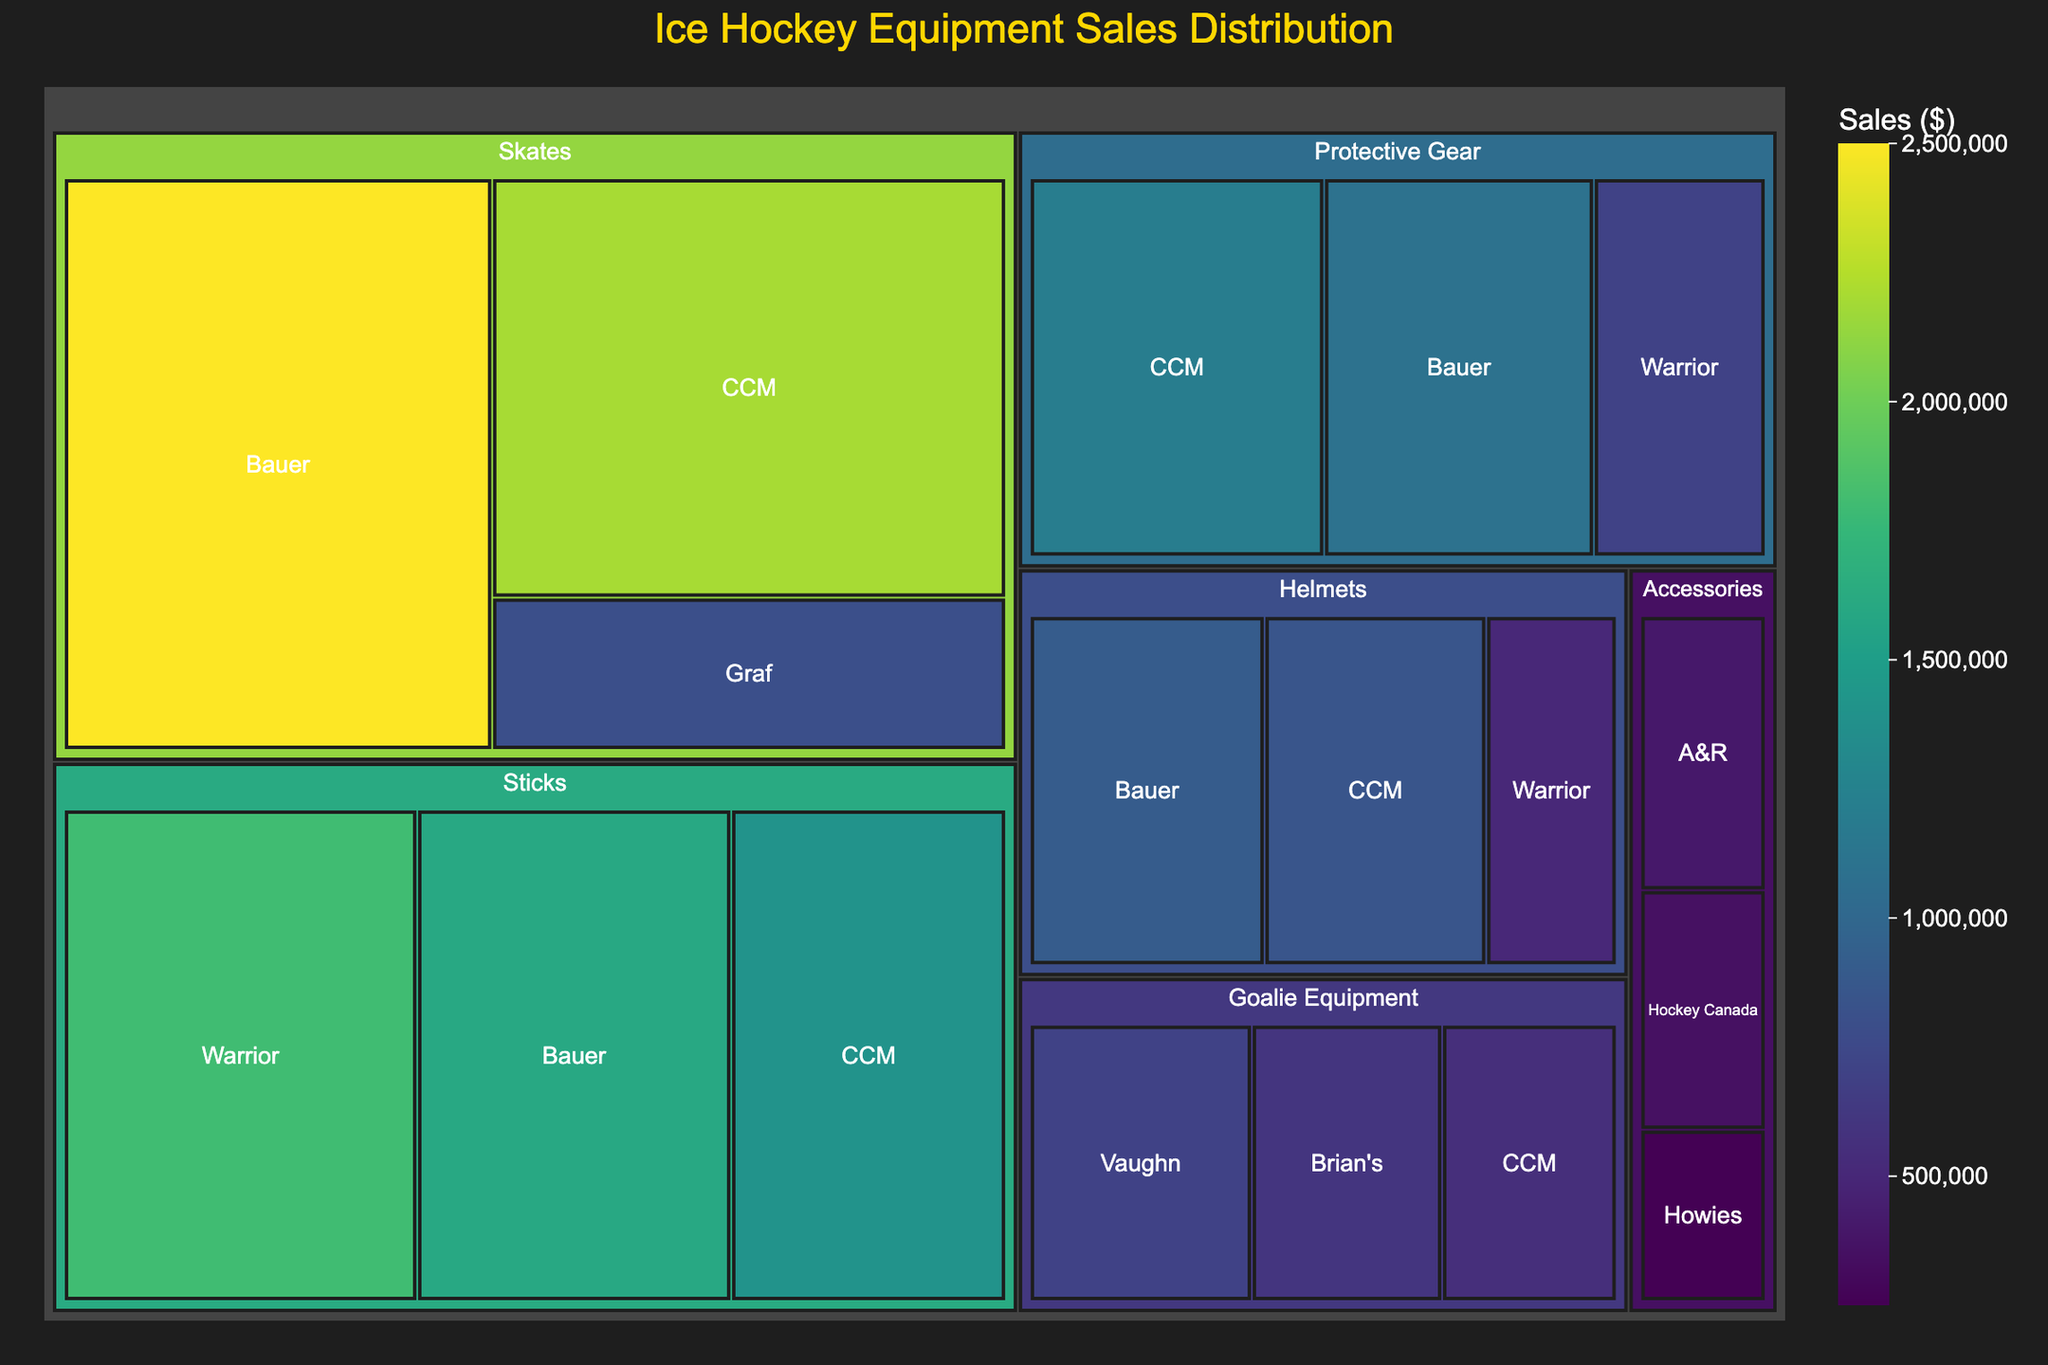What is the title of the treemap? The title is displayed prominently at the top of the treemap. It indicates what the chart is about.
Answer: Ice Hockey Equipment Sales Distribution Which category has the highest total sales? Sum the sales values of all brands within each category, then compare the sums.
Answer: Skates What is the sales value for Bauer skates? Look for the "Skates" category, then find Bauer within that category. The sales value is shown.
Answer: $2,500,000 Which brand has the lowest sales in the Helmets category? Look for the "Helmets" category and compare the sales values of Bauer, CCM, and Warrior.
Answer: Warrior How much more did Bauer sell in skates compared to CCM? Subtract the sales value of CCM skates from Bauer skates.
Answer: $300,000 What is the combined sales value of all brands in the Goalie Equipment category? Add up the sales values of Vaughn, Brian's, and CCM in the Goalie Equipment category.
Answer: $1,850,000 Which category is represented with the darkest color on the treemap? The darkest color corresponds to the highest total sales value. Identify the category with the darkest sections.
Answer: Skates Are there more brands in the Protective Gear category or in the Accessories category? Count the number of brands listed under each category.
Answer: Protective Gear Which category has the lowest total sales? Sum the sales values of each category and identify the one with the smallest total.
Answer: Accessories Compare the total sales of sticks and helmets. Which category sold more, and by how much? Sum the sales for all brands in each category, then compare the totals and calculate the difference.
Answer: Sticks sold more by $1,250,000 